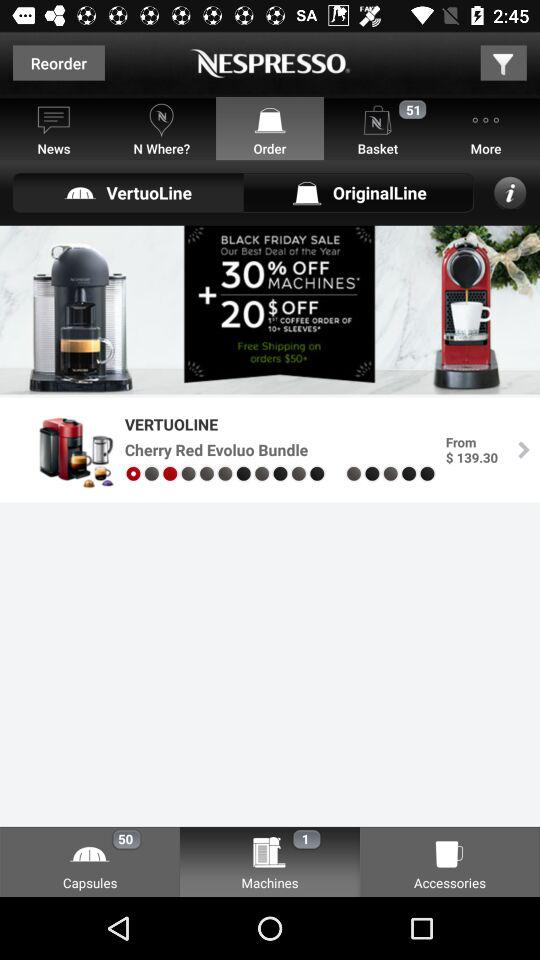What is the application's name? The application's name is "NESPRESSO". 